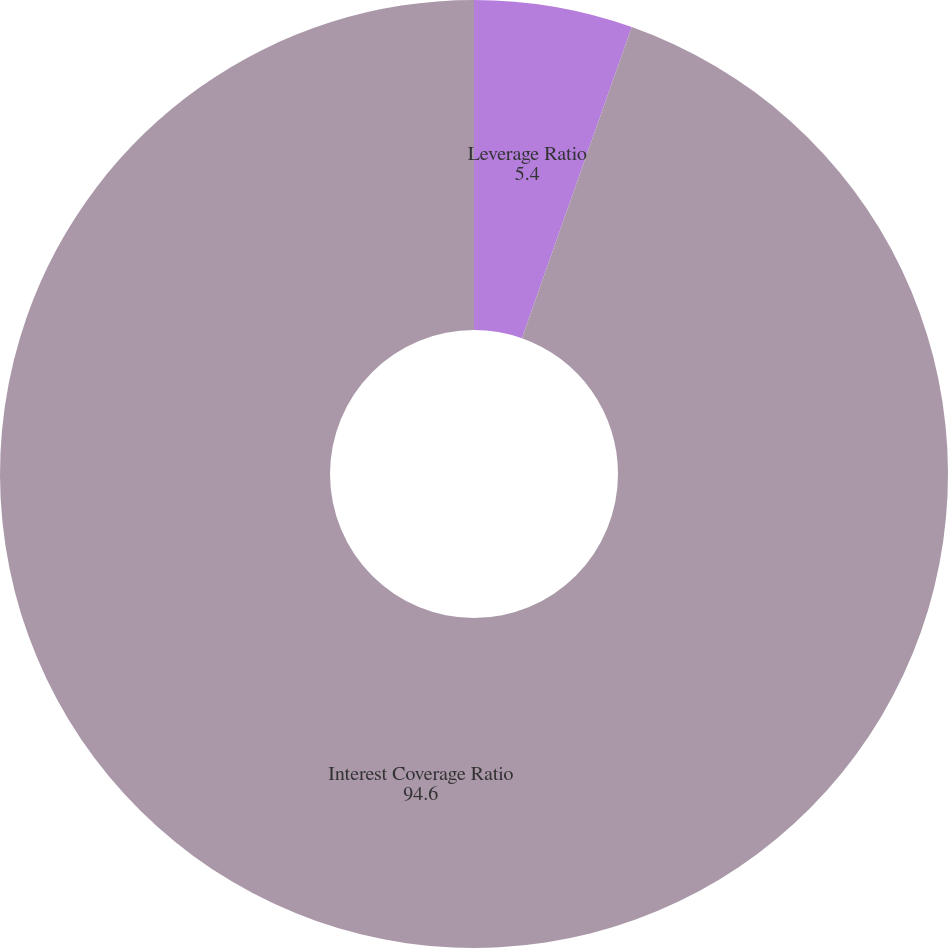Convert chart to OTSL. <chart><loc_0><loc_0><loc_500><loc_500><pie_chart><fcel>Leverage Ratio<fcel>Interest Coverage Ratio<nl><fcel>5.4%<fcel>94.6%<nl></chart> 